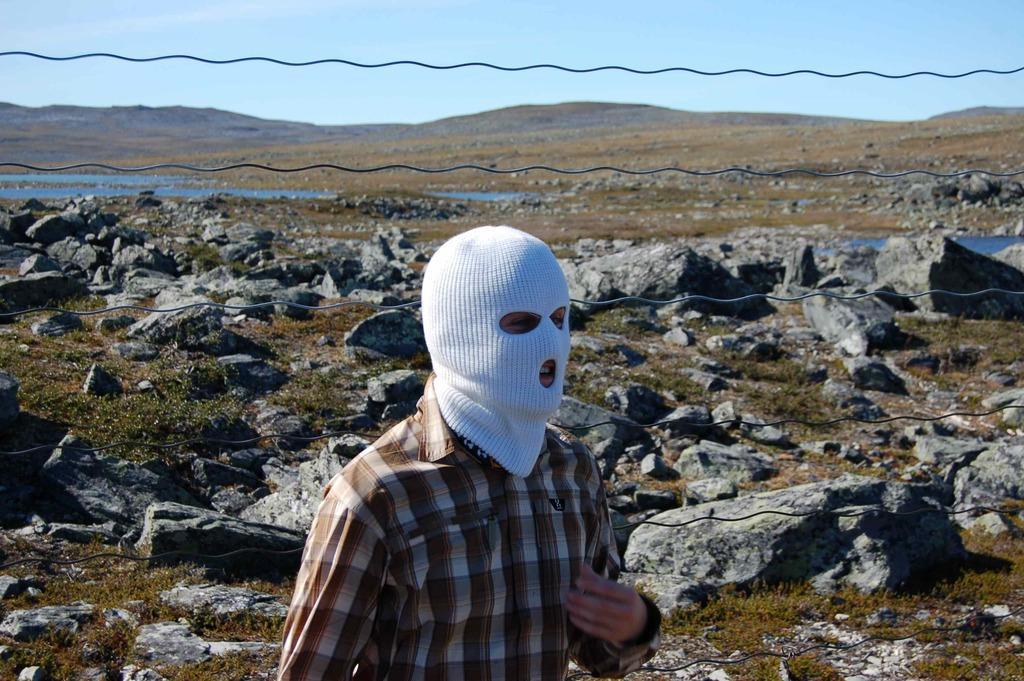Could you give a brief overview of what you see in this image? In this image in the foreground I can see a man standing and wearing a kind of mask and there are so many rocks on the ground and in the background I can see the sky. 